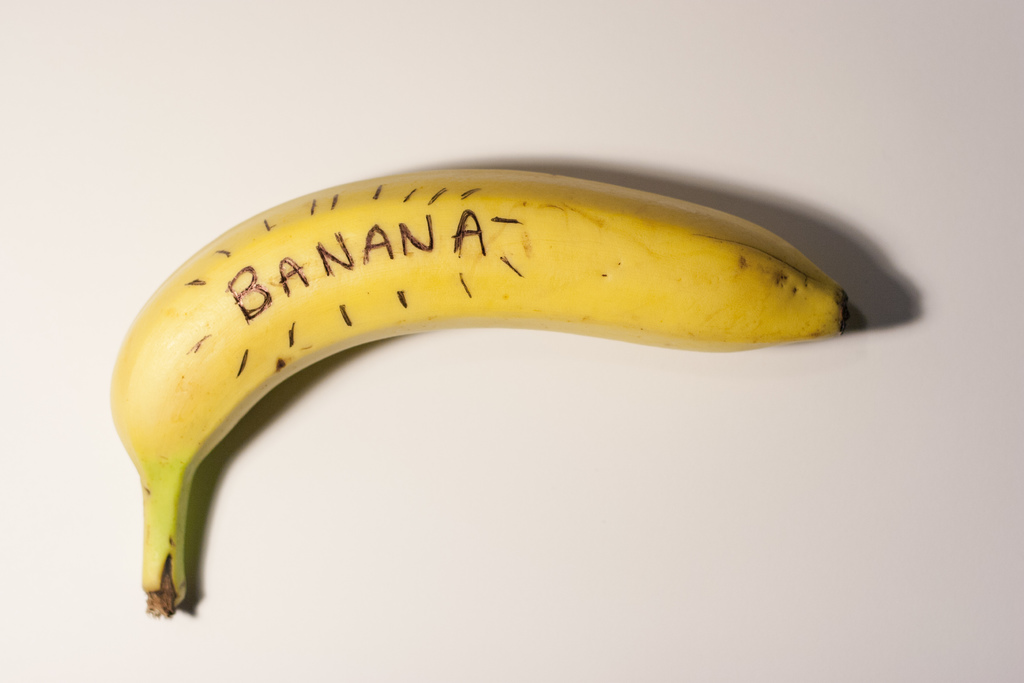Why might someone write 'BANANA' on a banana? Writing 'BANANA' directly on a banana may serve several purposes. It could be a playful, creative expression or a practical joke. Artists or educators might use such a method for visual impact in presentations or exhibits. Additionally, it could be part of an art project emphasizing the often overlooked beauty of everyday objects by explicitly labeling them, thus inviting viewers to reconsider their perceptions. 